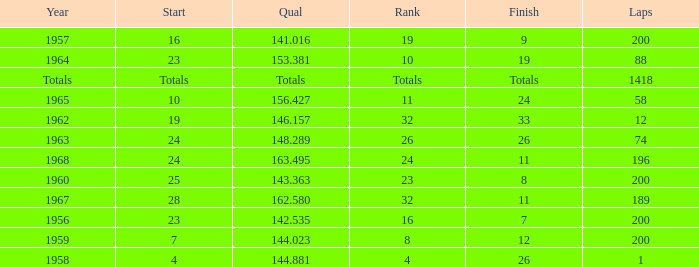Which qual also has a finish total of 9? 141.016. 